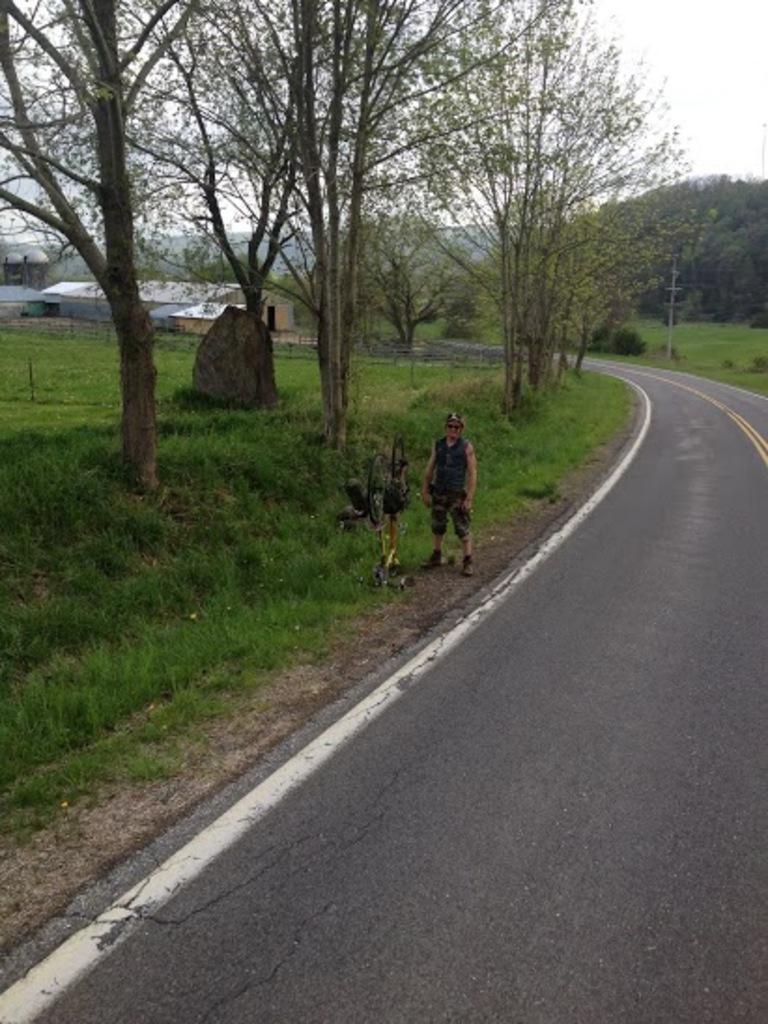Can you describe this image briefly? The man in black jacket who is wearing goggles and a cap is standing. Beside him, we see something in black color. At the bottom of the picture, we see the road. Beside him, we see grass and trees. There are trees and buildings in the background. On the right side, we see a pole. In the right top of the picture, we see the sky. 